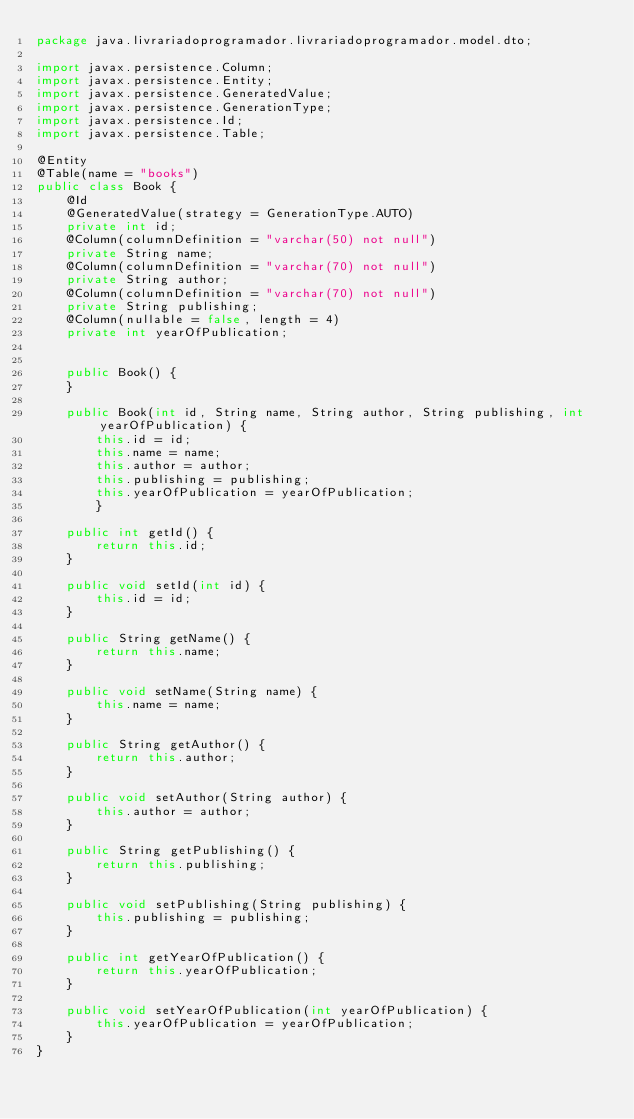<code> <loc_0><loc_0><loc_500><loc_500><_Java_>package java.livrariadoprogramador.livrariadoprogramador.model.dto;

import javax.persistence.Column;
import javax.persistence.Entity;
import javax.persistence.GeneratedValue;
import javax.persistence.GenerationType;
import javax.persistence.Id;
import javax.persistence.Table;

@Entity
@Table(name = "books")
public class Book {
    @Id
    @GeneratedValue(strategy = GenerationType.AUTO)
    private int id;
    @Column(columnDefinition = "varchar(50) not null")
    private String name;
    @Column(columnDefinition = "varchar(70) not null")
    private String author;
    @Column(columnDefinition = "varchar(70) not null")
    private String publishing;
    @Column(nullable = false, length = 4)
    private int yearOfPublication;


    public Book() {
    }

    public Book(int id, String name, String author, String publishing, int yearOfPublication) {
        this.id = id;
        this.name = name;
        this.author = author;
        this.publishing = publishing;
        this.yearOfPublication = yearOfPublication;
        }

    public int getId() {
        return this.id;
    }

    public void setId(int id) {
        this.id = id;
    }

    public String getName() {
        return this.name;
    }

    public void setName(String name) {
        this.name = name;
    }

    public String getAuthor() {
        return this.author;
    }

    public void setAuthor(String author) {
        this.author = author;
    }

    public String getPublishing() {
        return this.publishing;
    }

    public void setPublishing(String publishing) {
        this.publishing = publishing;
    }

    public int getYearOfPublication() {
        return this.yearOfPublication;
    }

    public void setYearOfPublication(int yearOfPublication) {
        this.yearOfPublication = yearOfPublication;
    }
}
</code> 